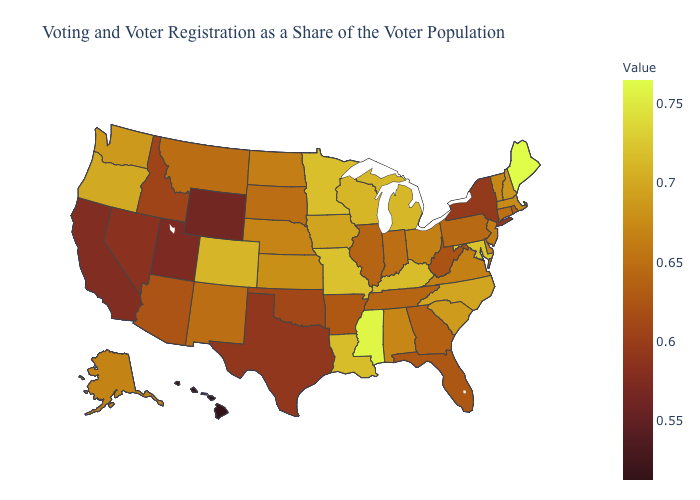Among the states that border North Dakota , does South Dakota have the lowest value?
Quick response, please. No. Does Illinois have the lowest value in the MidWest?
Answer briefly. Yes. Among the states that border Arizona , which have the highest value?
Quick response, please. Colorado. 